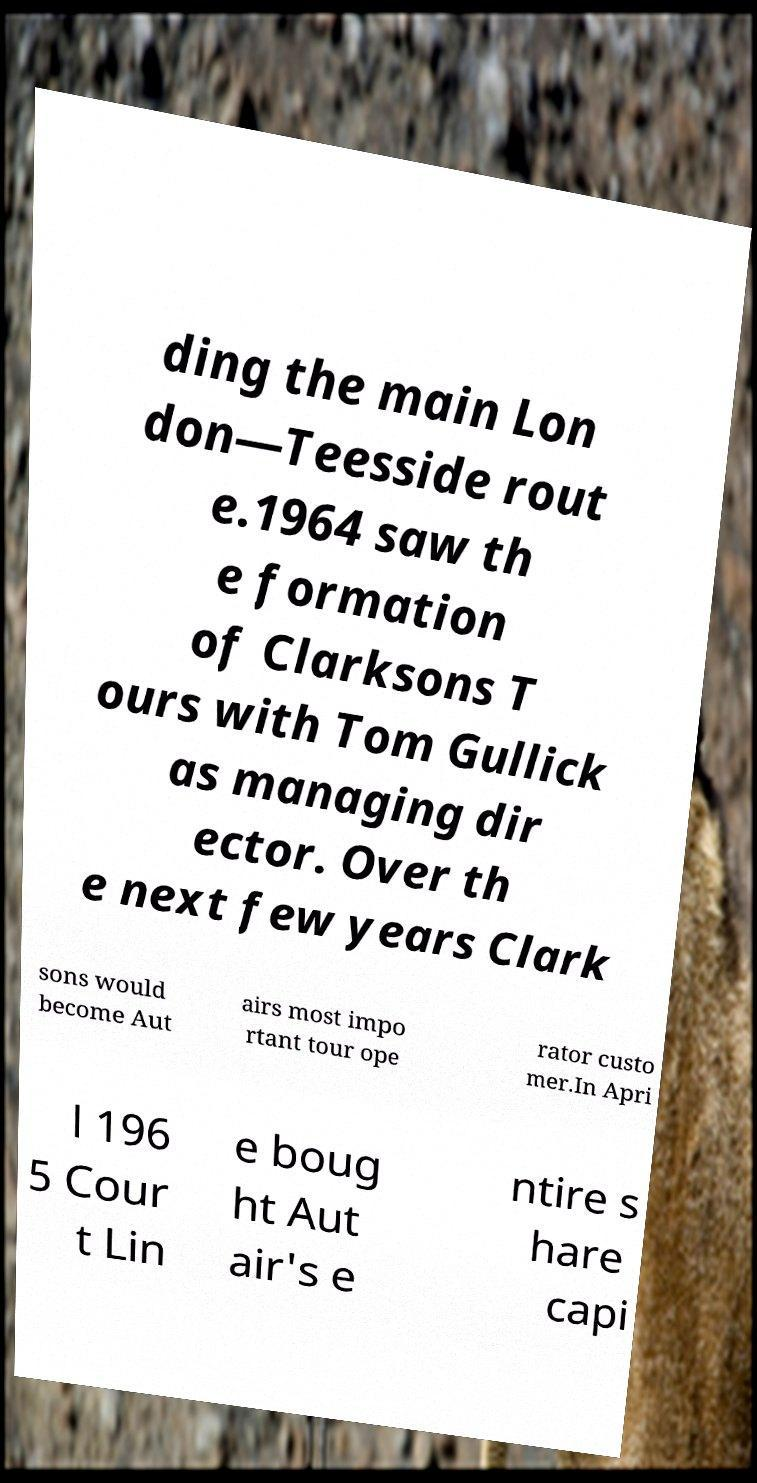There's text embedded in this image that I need extracted. Can you transcribe it verbatim? ding the main Lon don—Teesside rout e.1964 saw th e formation of Clarksons T ours with Tom Gullick as managing dir ector. Over th e next few years Clark sons would become Aut airs most impo rtant tour ope rator custo mer.In Apri l 196 5 Cour t Lin e boug ht Aut air's e ntire s hare capi 